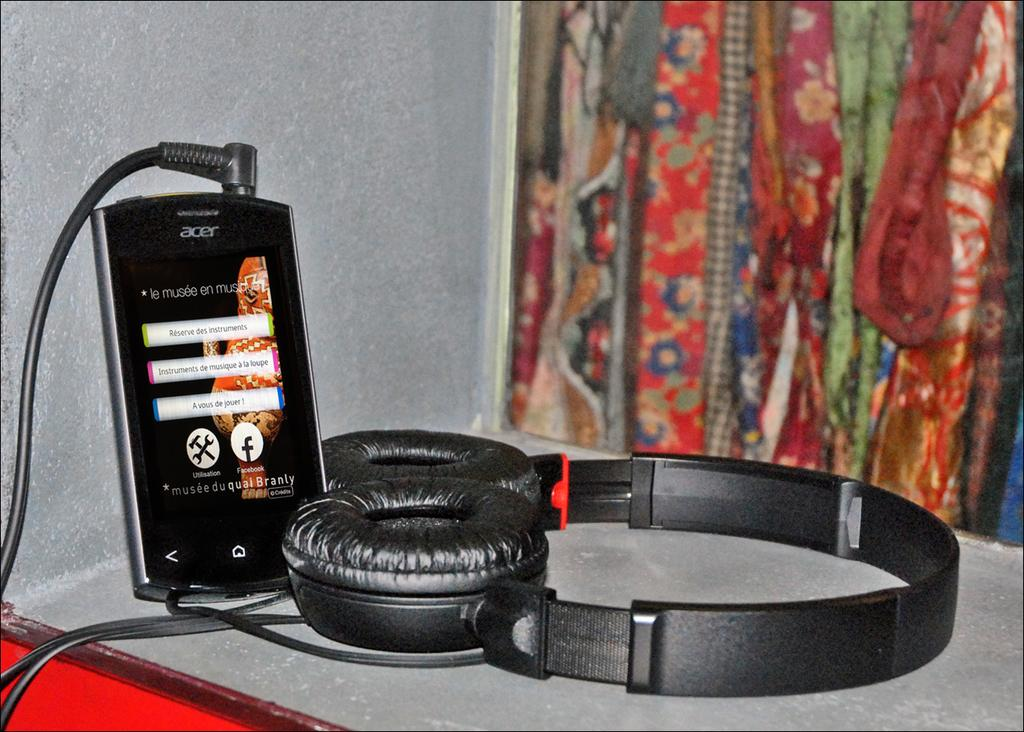What electronic device is visible in the image? There is a mobile device in the image. What is the mobile device connected to? There is a headset in the image, which is likely connected to the mobile device. Where are the mobile device and headset located? Both the mobile device and headset are on a desk in the image. What can be seen on the right side of the image? There appears to be a window on the right side of the image. What is visible in the background of the image? There is a wall visible in the background of the image. Can you see a crown on the head of the person using the mobile device in the image? There is no person visible in the image, and therefore no crown can be seen on their head. 